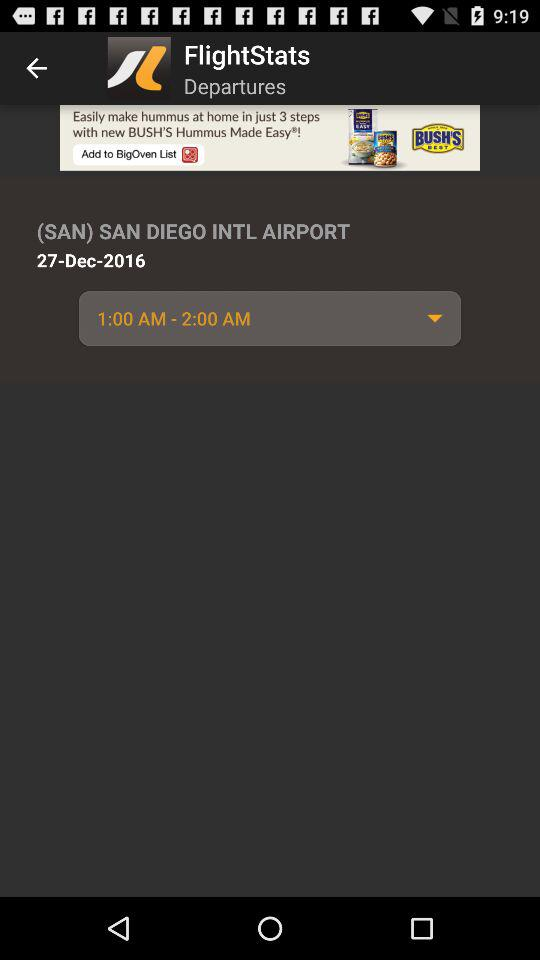What is the date? The date is December 27, 2016. 